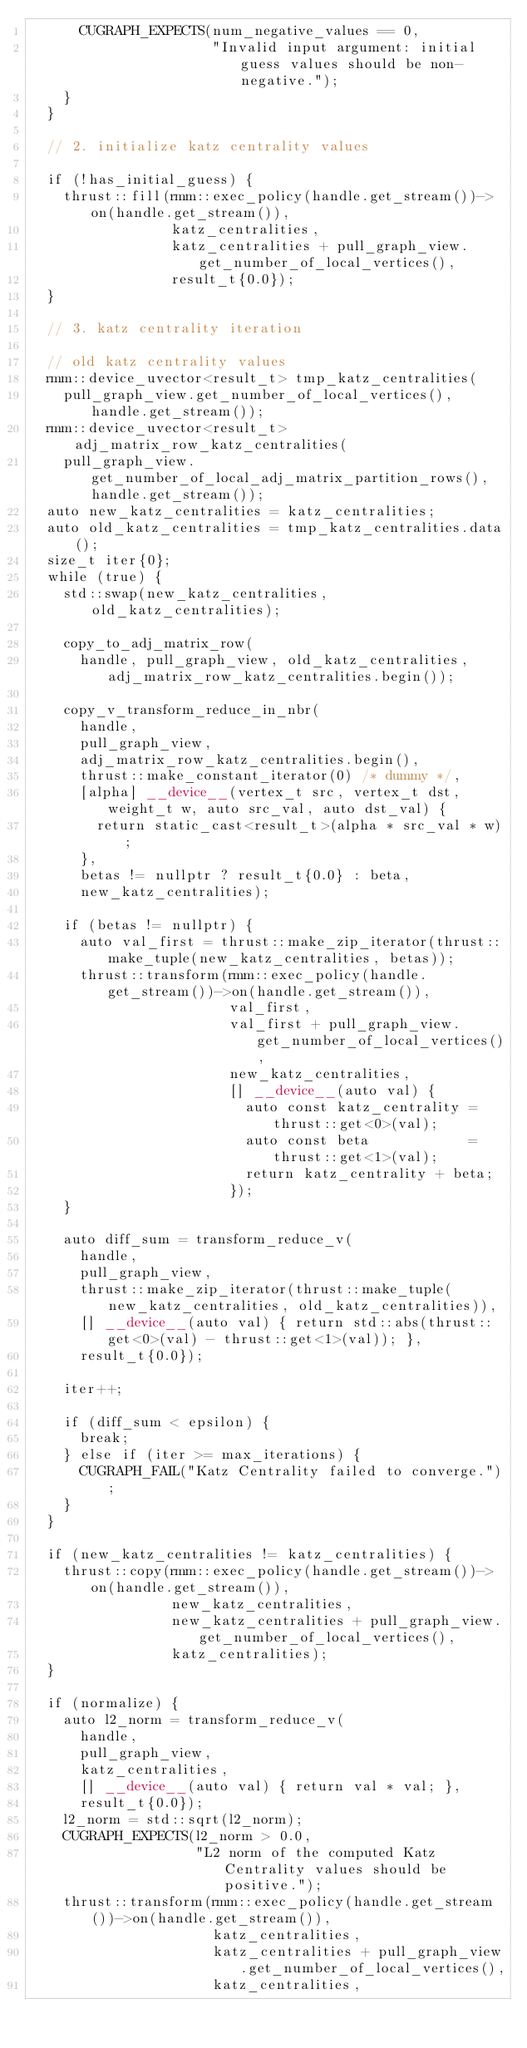Convert code to text. <code><loc_0><loc_0><loc_500><loc_500><_Cuda_>      CUGRAPH_EXPECTS(num_negative_values == 0,
                      "Invalid input argument: initial guess values should be non-negative.");
    }
  }

  // 2. initialize katz centrality values

  if (!has_initial_guess) {
    thrust::fill(rmm::exec_policy(handle.get_stream())->on(handle.get_stream()),
                 katz_centralities,
                 katz_centralities + pull_graph_view.get_number_of_local_vertices(),
                 result_t{0.0});
  }

  // 3. katz centrality iteration

  // old katz centrality values
  rmm::device_uvector<result_t> tmp_katz_centralities(
    pull_graph_view.get_number_of_local_vertices(), handle.get_stream());
  rmm::device_uvector<result_t> adj_matrix_row_katz_centralities(
    pull_graph_view.get_number_of_local_adj_matrix_partition_rows(), handle.get_stream());
  auto new_katz_centralities = katz_centralities;
  auto old_katz_centralities = tmp_katz_centralities.data();
  size_t iter{0};
  while (true) {
    std::swap(new_katz_centralities, old_katz_centralities);

    copy_to_adj_matrix_row(
      handle, pull_graph_view, old_katz_centralities, adj_matrix_row_katz_centralities.begin());

    copy_v_transform_reduce_in_nbr(
      handle,
      pull_graph_view,
      adj_matrix_row_katz_centralities.begin(),
      thrust::make_constant_iterator(0) /* dummy */,
      [alpha] __device__(vertex_t src, vertex_t dst, weight_t w, auto src_val, auto dst_val) {
        return static_cast<result_t>(alpha * src_val * w);
      },
      betas != nullptr ? result_t{0.0} : beta,
      new_katz_centralities);

    if (betas != nullptr) {
      auto val_first = thrust::make_zip_iterator(thrust::make_tuple(new_katz_centralities, betas));
      thrust::transform(rmm::exec_policy(handle.get_stream())->on(handle.get_stream()),
                        val_first,
                        val_first + pull_graph_view.get_number_of_local_vertices(),
                        new_katz_centralities,
                        [] __device__(auto val) {
                          auto const katz_centrality = thrust::get<0>(val);
                          auto const beta            = thrust::get<1>(val);
                          return katz_centrality + beta;
                        });
    }

    auto diff_sum = transform_reduce_v(
      handle,
      pull_graph_view,
      thrust::make_zip_iterator(thrust::make_tuple(new_katz_centralities, old_katz_centralities)),
      [] __device__(auto val) { return std::abs(thrust::get<0>(val) - thrust::get<1>(val)); },
      result_t{0.0});

    iter++;

    if (diff_sum < epsilon) {
      break;
    } else if (iter >= max_iterations) {
      CUGRAPH_FAIL("Katz Centrality failed to converge.");
    }
  }

  if (new_katz_centralities != katz_centralities) {
    thrust::copy(rmm::exec_policy(handle.get_stream())->on(handle.get_stream()),
                 new_katz_centralities,
                 new_katz_centralities + pull_graph_view.get_number_of_local_vertices(),
                 katz_centralities);
  }

  if (normalize) {
    auto l2_norm = transform_reduce_v(
      handle,
      pull_graph_view,
      katz_centralities,
      [] __device__(auto val) { return val * val; },
      result_t{0.0});
    l2_norm = std::sqrt(l2_norm);
    CUGRAPH_EXPECTS(l2_norm > 0.0,
                    "L2 norm of the computed Katz Centrality values should be positive.");
    thrust::transform(rmm::exec_policy(handle.get_stream())->on(handle.get_stream()),
                      katz_centralities,
                      katz_centralities + pull_graph_view.get_number_of_local_vertices(),
                      katz_centralities,</code> 